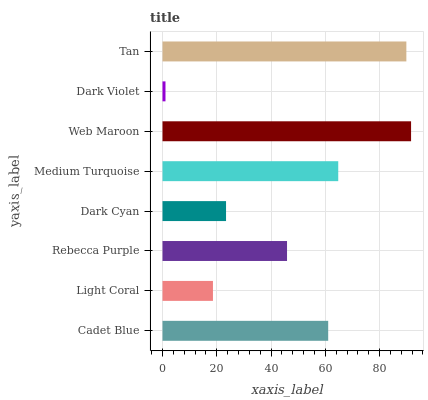Is Dark Violet the minimum?
Answer yes or no. Yes. Is Web Maroon the maximum?
Answer yes or no. Yes. Is Light Coral the minimum?
Answer yes or no. No. Is Light Coral the maximum?
Answer yes or no. No. Is Cadet Blue greater than Light Coral?
Answer yes or no. Yes. Is Light Coral less than Cadet Blue?
Answer yes or no. Yes. Is Light Coral greater than Cadet Blue?
Answer yes or no. No. Is Cadet Blue less than Light Coral?
Answer yes or no. No. Is Cadet Blue the high median?
Answer yes or no. Yes. Is Rebecca Purple the low median?
Answer yes or no. Yes. Is Dark Violet the high median?
Answer yes or no. No. Is Light Coral the low median?
Answer yes or no. No. 